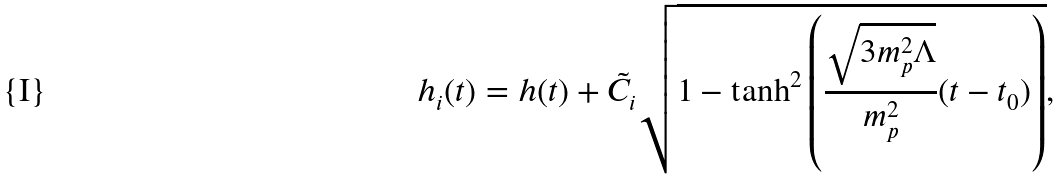Convert formula to latex. <formula><loc_0><loc_0><loc_500><loc_500>h _ { i } ( t ) = h ( t ) + \tilde { C } _ { i } \sqrt { 1 - \tanh ^ { 2 } \left ( \frac { \sqrt { 3 m _ { p } ^ { 2 } \Lambda } } { m _ { p } ^ { 2 } } ( t - t _ { 0 } ) \right ) } ,</formula> 